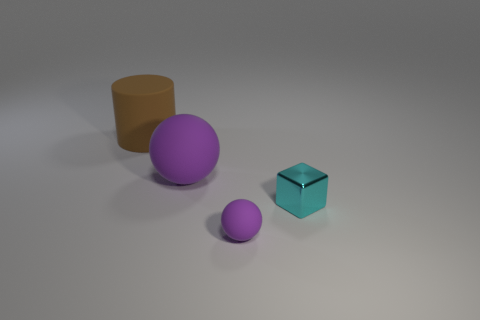Do the thing in front of the metallic cube and the large matte cylinder have the same size?
Ensure brevity in your answer.  No. There is a ball in front of the shiny thing; is it the same color as the large ball?
Your answer should be compact. Yes. How many things are either large matte things in front of the brown cylinder or large cyan things?
Your response must be concise. 1. There is a object to the right of the purple object to the right of the matte ball on the left side of the small rubber thing; what is it made of?
Ensure brevity in your answer.  Metal. Are there more big purple matte things that are right of the brown matte thing than large rubber things to the right of the small purple rubber sphere?
Provide a succinct answer. Yes. How many blocks are either big objects or large brown matte things?
Offer a very short reply. 0. How many purple matte spheres are right of the purple ball that is left of the purple thing that is in front of the small metallic cube?
Your answer should be very brief. 1. Are there more big red spheres than purple rubber spheres?
Offer a terse response. No. Is the cyan object the same size as the brown rubber cylinder?
Provide a short and direct response. No. How many objects are small gray shiny cubes or cyan shiny objects?
Your answer should be compact. 1. 